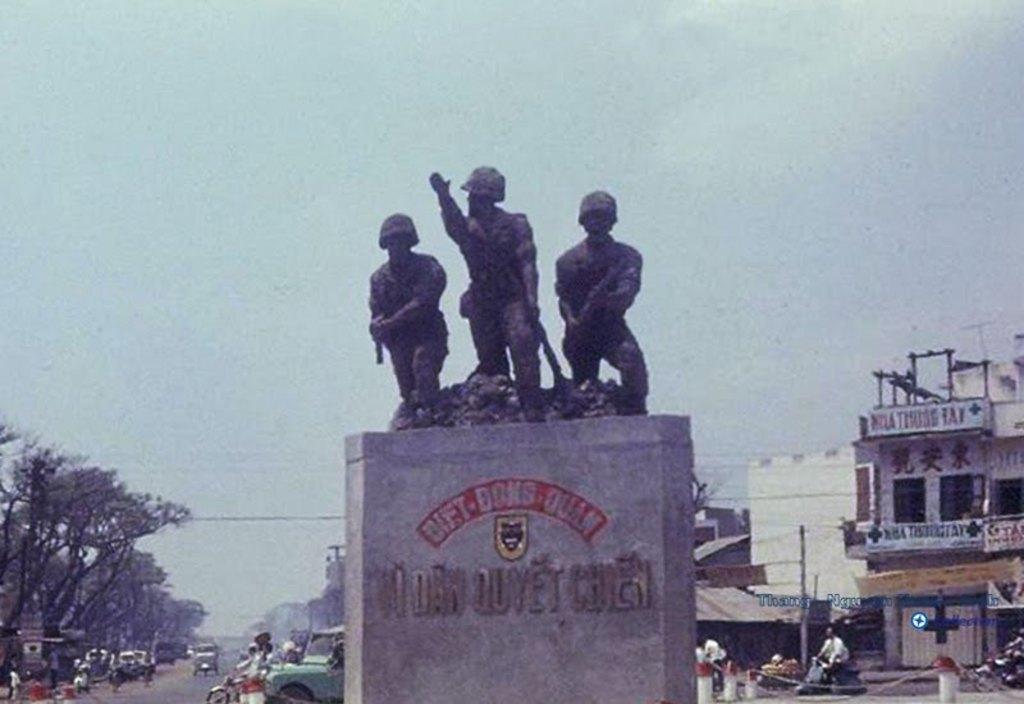Can you describe this image briefly? In the center of the image there are statues and there is text on the wall. In the background of the image there are vehicles on the road. There are trees to the left side of the image. To the right side of the image there are houses. At the top of the image there is sky. 